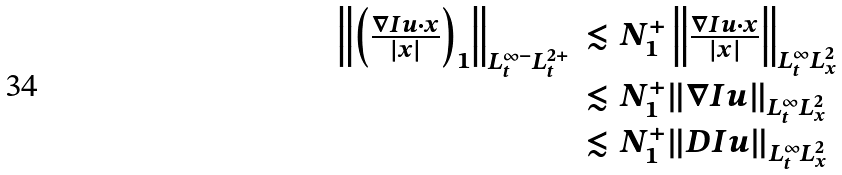Convert formula to latex. <formula><loc_0><loc_0><loc_500><loc_500>\begin{array} { l l } \left \| \left ( \frac { \nabla I u \cdot x } { | x | } \right ) _ { 1 } \right \| _ { L _ { t } ^ { \infty - } L _ { t } ^ { 2 + } } & \lesssim N _ { 1 } ^ { + } \left \| \frac { \nabla I u \cdot x } { | x | } \right \| _ { L _ { t } ^ { \infty } L _ { x } ^ { 2 } } \\ & \lesssim N _ { 1 } ^ { + } \| \nabla I u \| _ { L _ { t } ^ { \infty } L _ { x } ^ { 2 } } \\ & \lesssim N _ { 1 } ^ { + } \| D I u \| _ { L _ { t } ^ { \infty } L _ { x } ^ { 2 } } \end{array}</formula> 